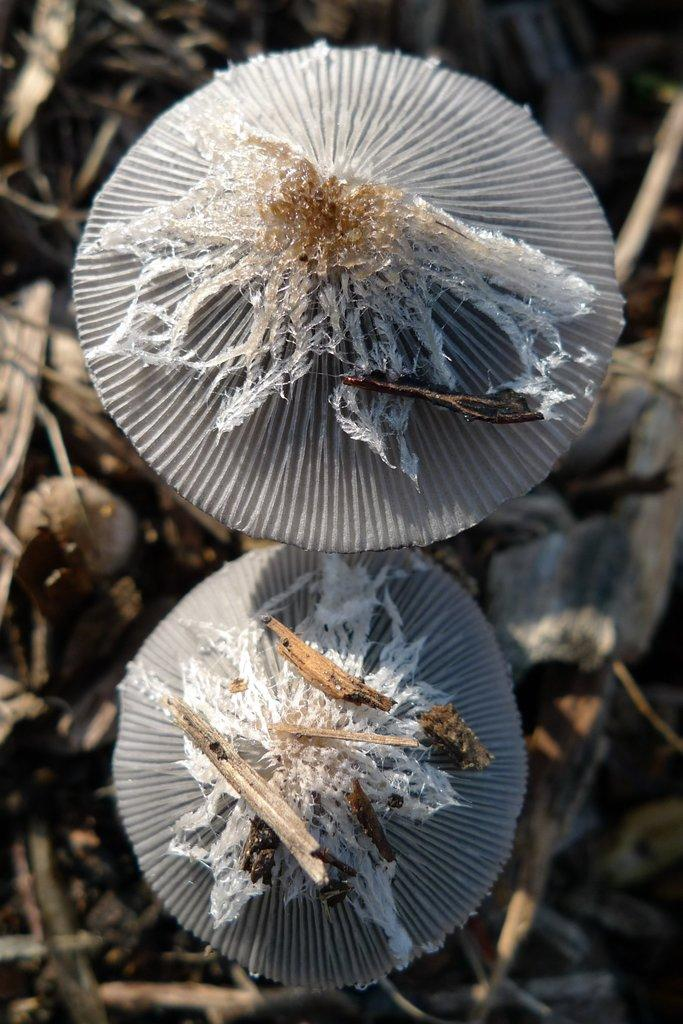How many mushrooms are in the image? There are two mushrooms in the image. What else can be seen at the bottom of the image? There are sticks at the bottom of the image. What type of noise can be heard coming from the mushrooms in the image? There is no noise coming from the mushrooms in the image, as they are inanimate objects and do not produce sound. 